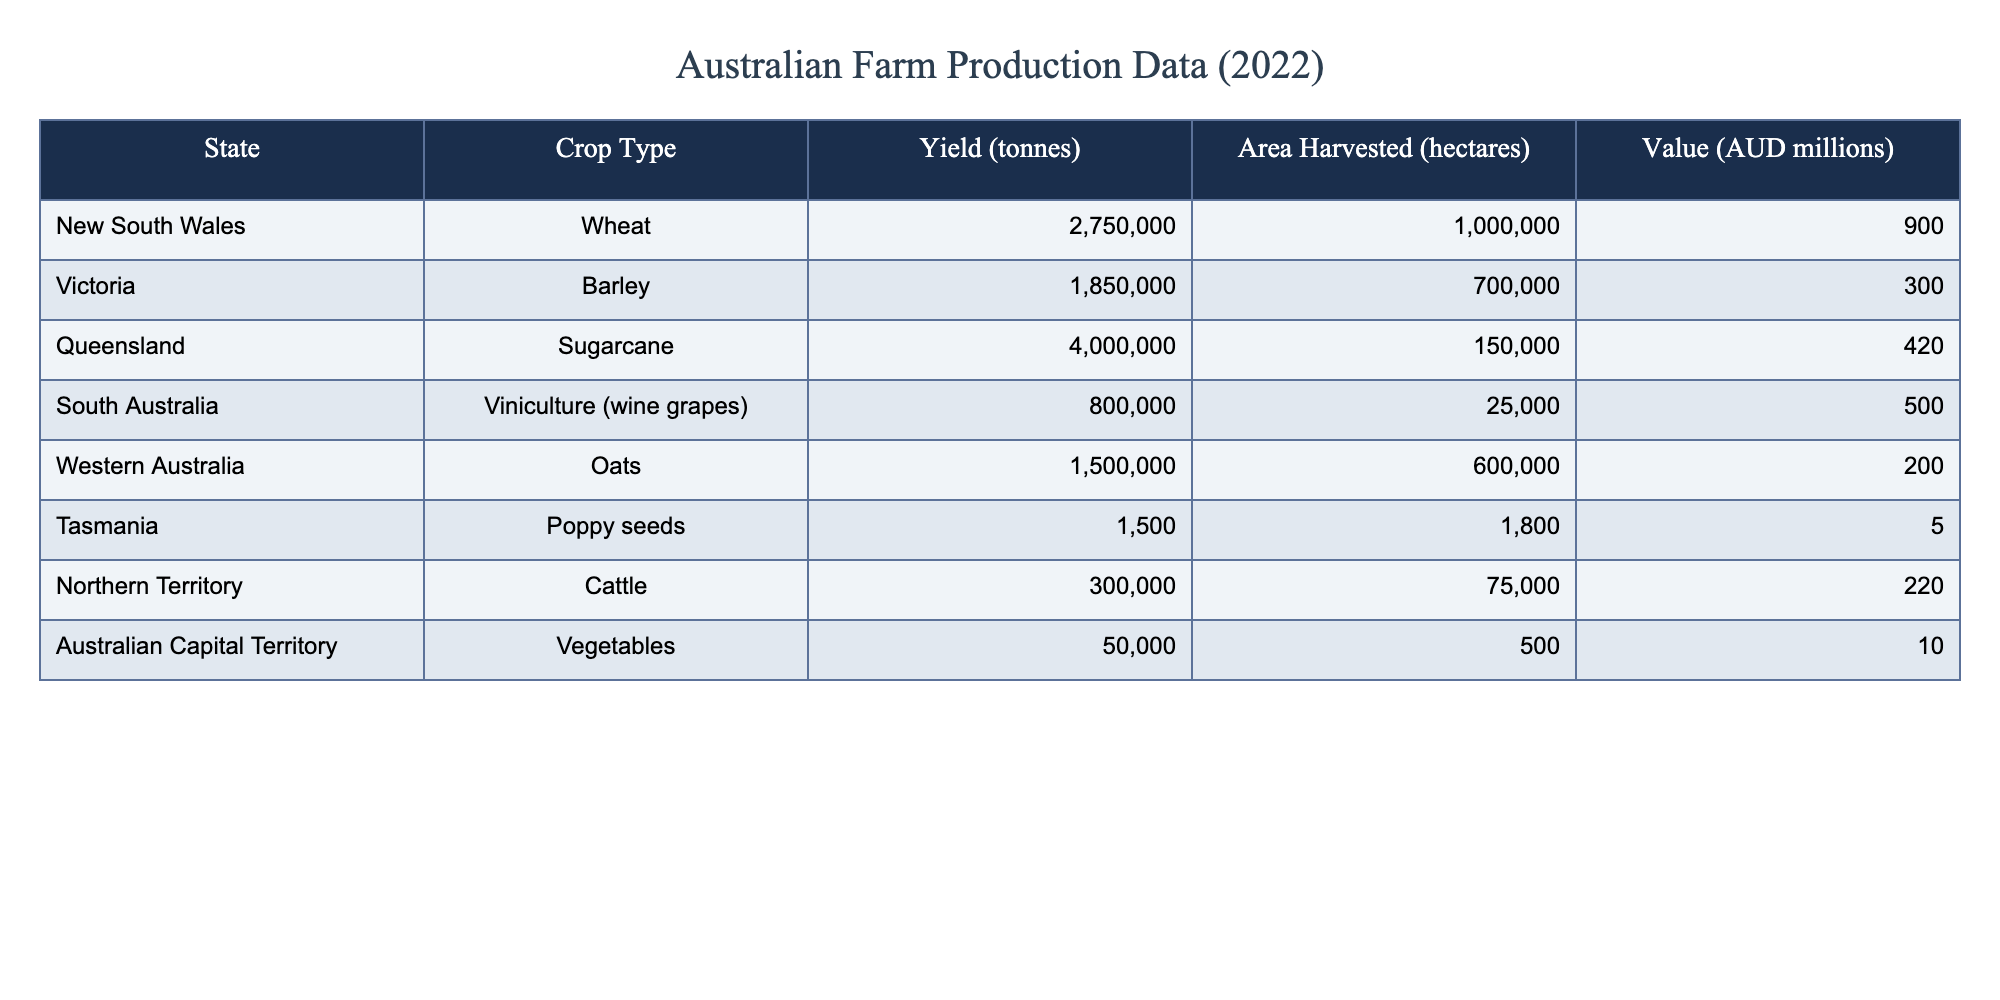What is the yield of wheat in New South Wales? The yield for wheat in New South Wales is provided in the table under the "Yield (tonnes)" column. The value listed there is 2,750,000 tonnes.
Answer: 2,750,000 tonnes How much area was harvested for barley in Victoria? The area harvested for barley can be found in the table under the "Area Harvested (hectares)" column for Victoria. It indicates that 700,000 hectares were harvested.
Answer: 700,000 hectares Is the value of sugarcane production in Queensland higher than that of cattle in the Northern Territory? We look at the value for sugarcane and cattle. The value for sugarcane in Queensland is 420 million AUD, and for cattle in the Northern Territory, it is 220 million AUD. Since 420 million is higher than 220 million, the statement is true.
Answer: Yes What is the total value of farm production for Tasmania and the Australian Capital Territory combined? To find the total value for both regions, we must identify the values from the table: Tasmania has a value of 5 million AUD, and the Australian Capital Territory has a value of 10 million AUD. Adding these gives us 5 + 10 = 15 million AUD.
Answer: 15 million AUD Which state has the highest yield and what is the amount? We must compare the yields from different states listed in the table. The highest yield is found in Queensland for sugarcane with 4,000,000 tonnes. Thus, the answer highlights both the state and the specific yield amount.
Answer: Queensland, 4,000,000 tonnes What is the average yield across all crops listed in the table? First, we gather all the yield figures: 2,750,000 (Wheat), 1,850,000 (Barley), 4,000,000 (Sugarcane), 800,000 (Viniculture), 1,500,000 (Oats), 1,500 (Poppy seeds), 300,000 (Cattle), and 50,000 (Vegetables). Summing these yields gives us a total of 12,252,500 tonnes. Since there are 8 crops, the average yield is 12,252,500 / 8, which equals 1,531,562.5 tonnes.
Answer: 1,531,562.5 tonnes Is the harvested area for oats in Western Australia more than the area harvested for wheat in New South Wales? We need to compare the area harvested for both crops as indicated in the table: oats in Western Australia is 600,000 hectares while wheat in New South Wales is 1,000,000 hectares. Since 600,000 is less than 1,000,000, the statement is false.
Answer: No What is the difference in value between the viniculture in South Australia and the sugarcane in Queensland? First, we identify the values: viniculture in South Australia is 500 million AUD, while sugarcane in Queensland is 420 million AUD. The difference is calculated as 500 - 420 = 80 million AUD.
Answer: 80 million AUD 